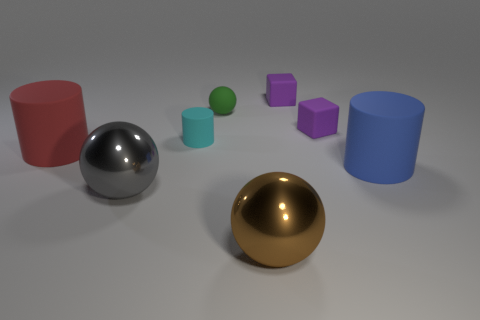Could you describe the lighting setup in this scene? The scene is illuminated with soft, diffused lighting that suggests an indoor setting, likely from overhead sources due to the gentle shadows cast directly underneath the objects, indicating an evenly lit environment often used in product visualization or 3D modeling. 